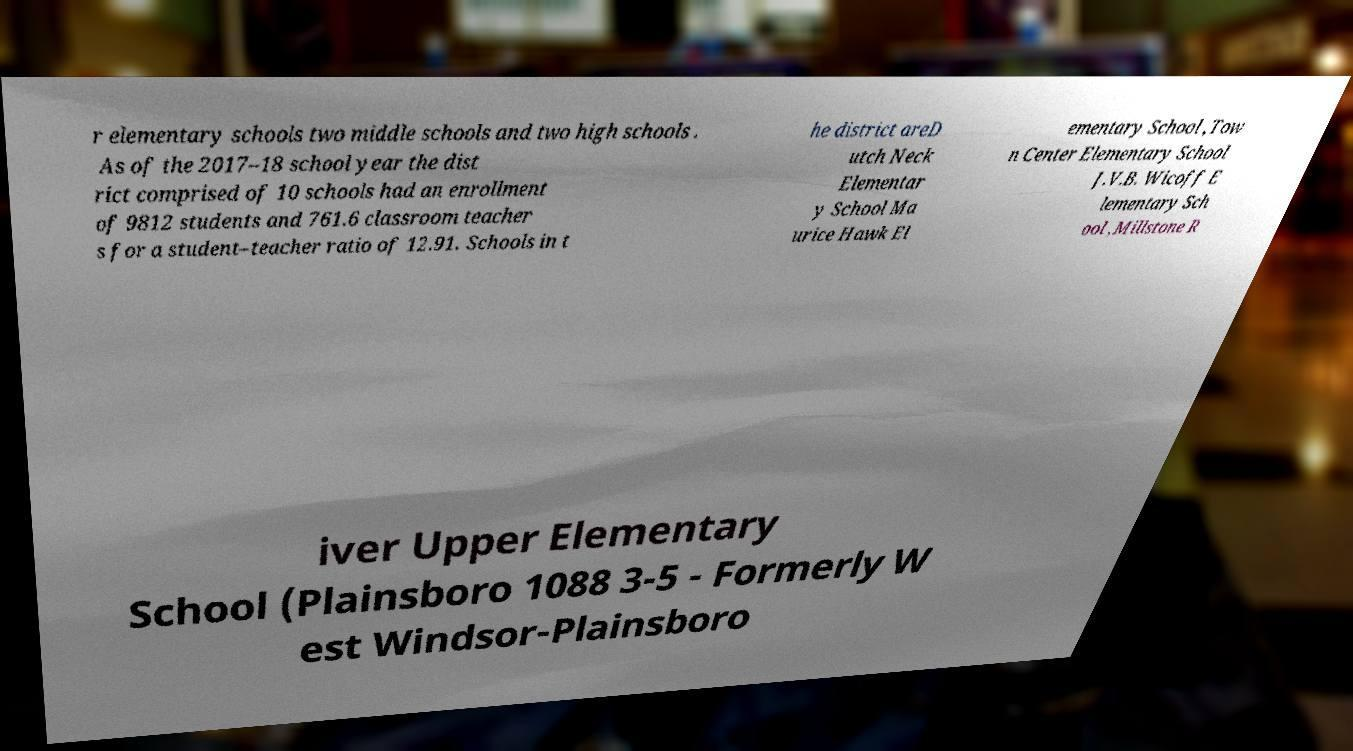Could you assist in decoding the text presented in this image and type it out clearly? r elementary schools two middle schools and two high schools . As of the 2017–18 school year the dist rict comprised of 10 schools had an enrollment of 9812 students and 761.6 classroom teacher s for a student–teacher ratio of 12.91. Schools in t he district areD utch Neck Elementar y School Ma urice Hawk El ementary School ,Tow n Center Elementary School J.V.B. Wicoff E lementary Sch ool ,Millstone R iver Upper Elementary School (Plainsboro 1088 3-5 - Formerly W est Windsor-Plainsboro 